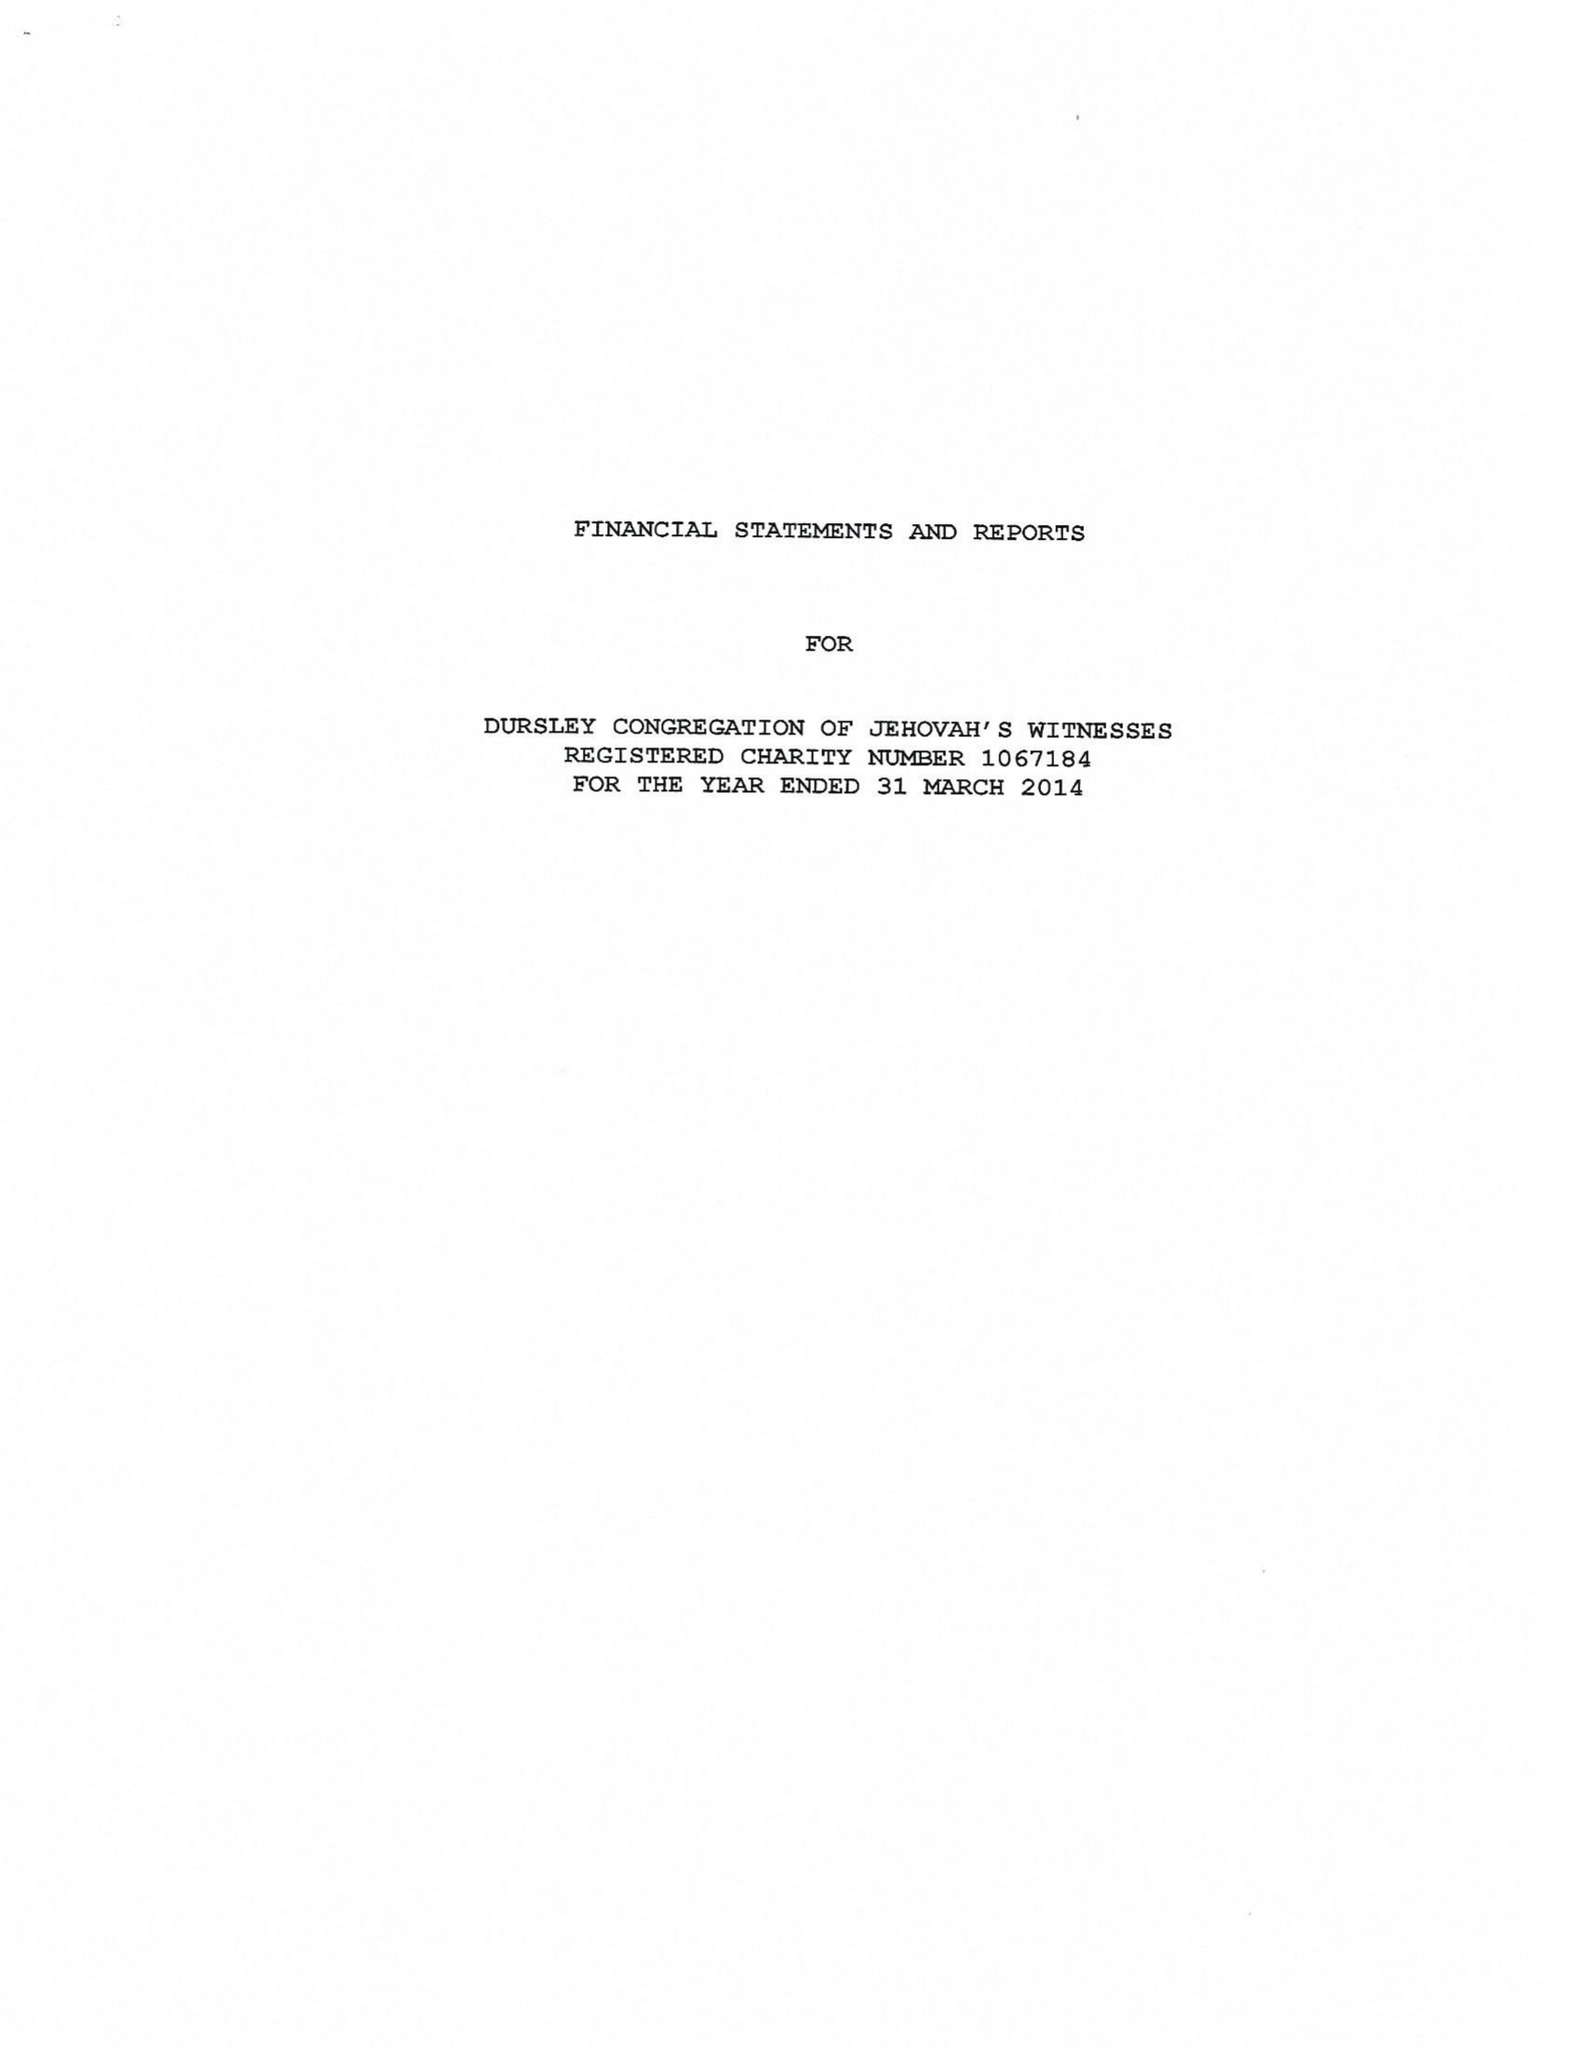What is the value for the spending_annually_in_british_pounds?
Answer the question using a single word or phrase. 129013.00 